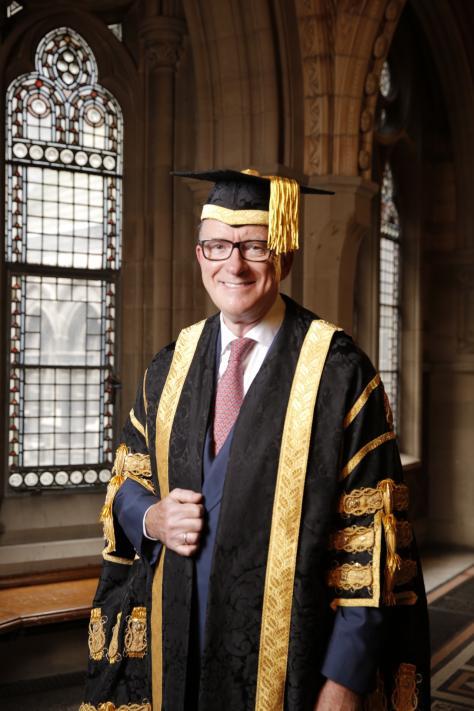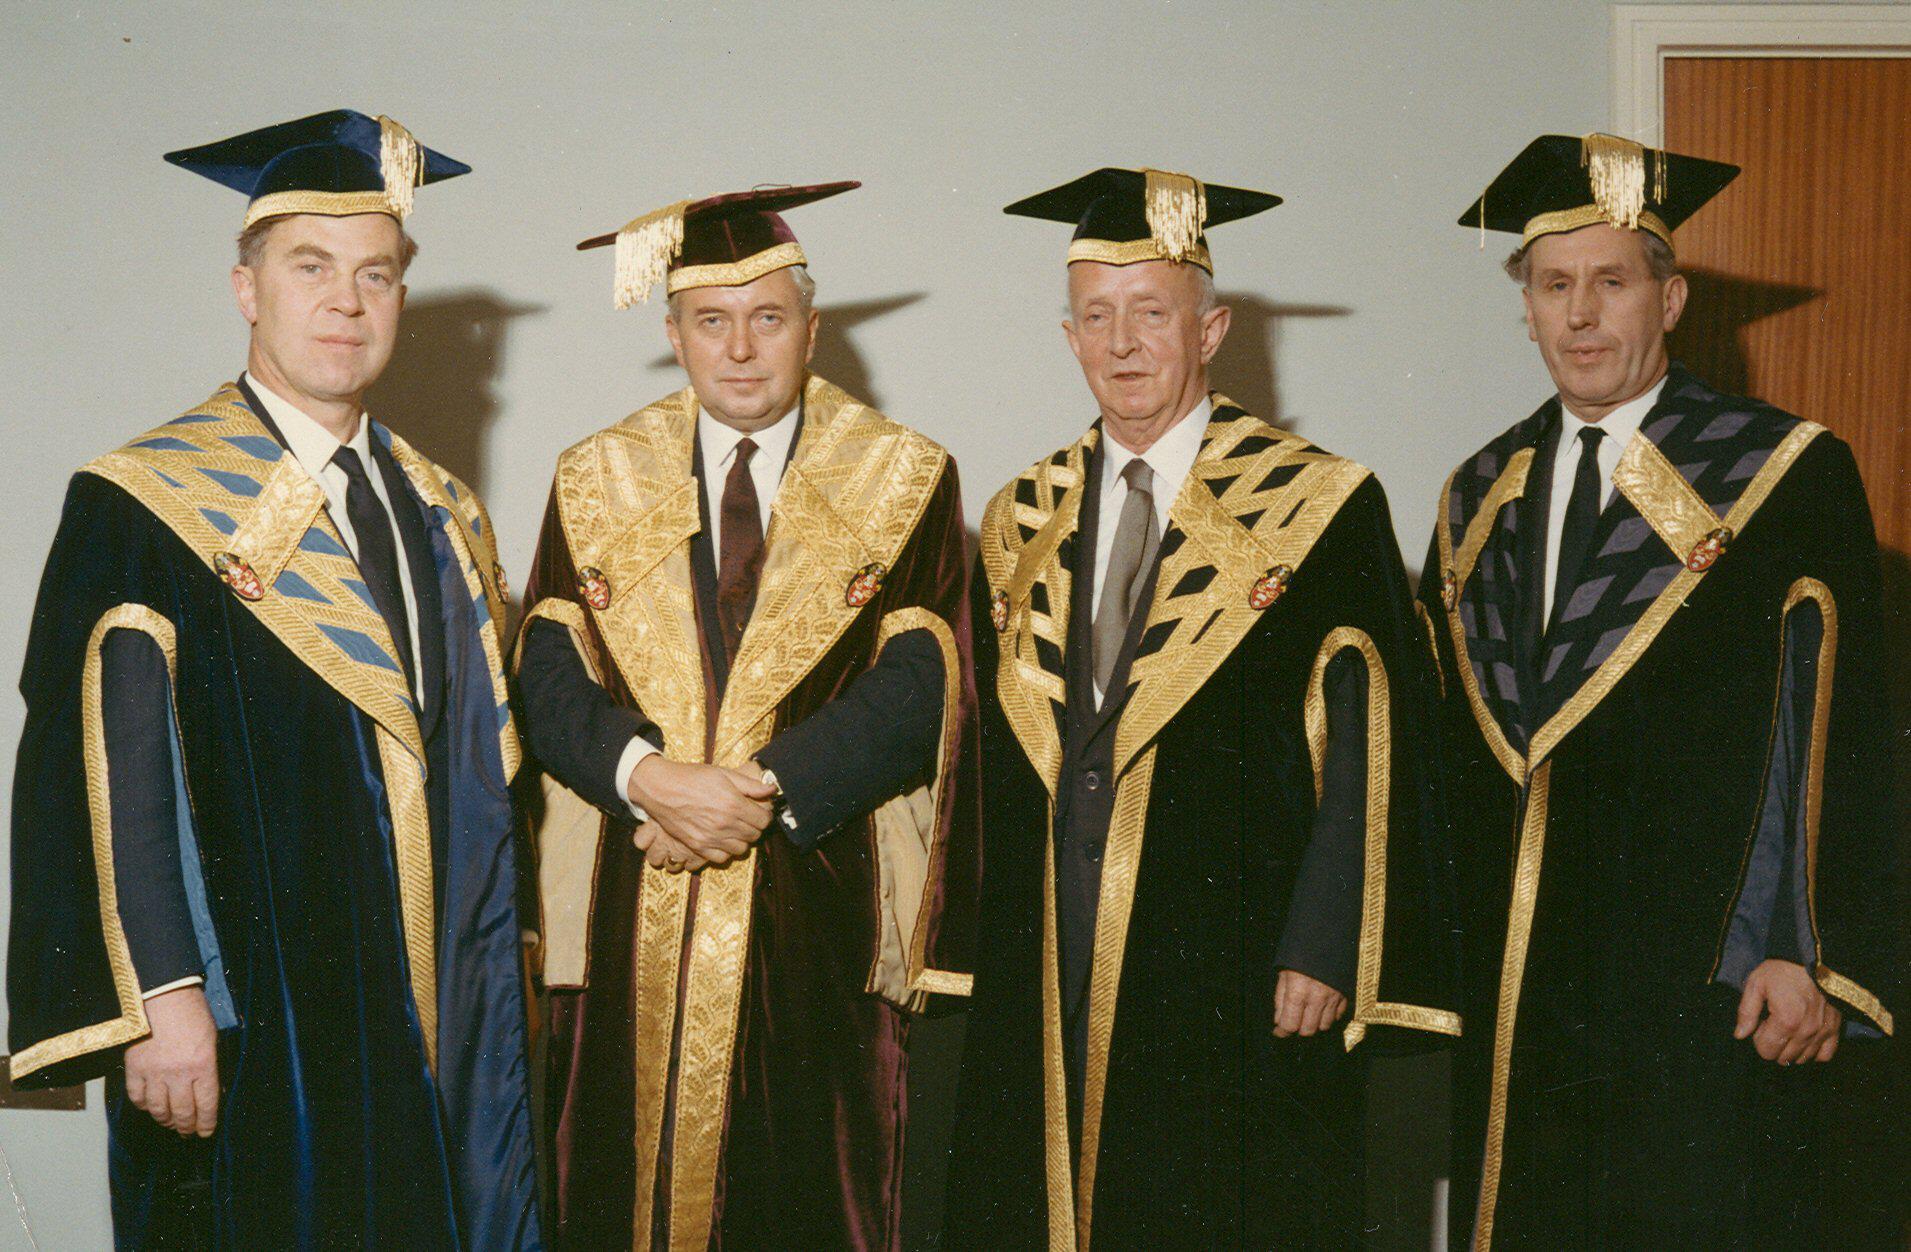The first image is the image on the left, the second image is the image on the right. Analyze the images presented: Is the assertion "There are at least eight people in total." valid? Answer yes or no. No. The first image is the image on the left, the second image is the image on the right. Analyze the images presented: Is the assertion "The right image contains exactly four humans wearing graduation uniforms." valid? Answer yes or no. Yes. 